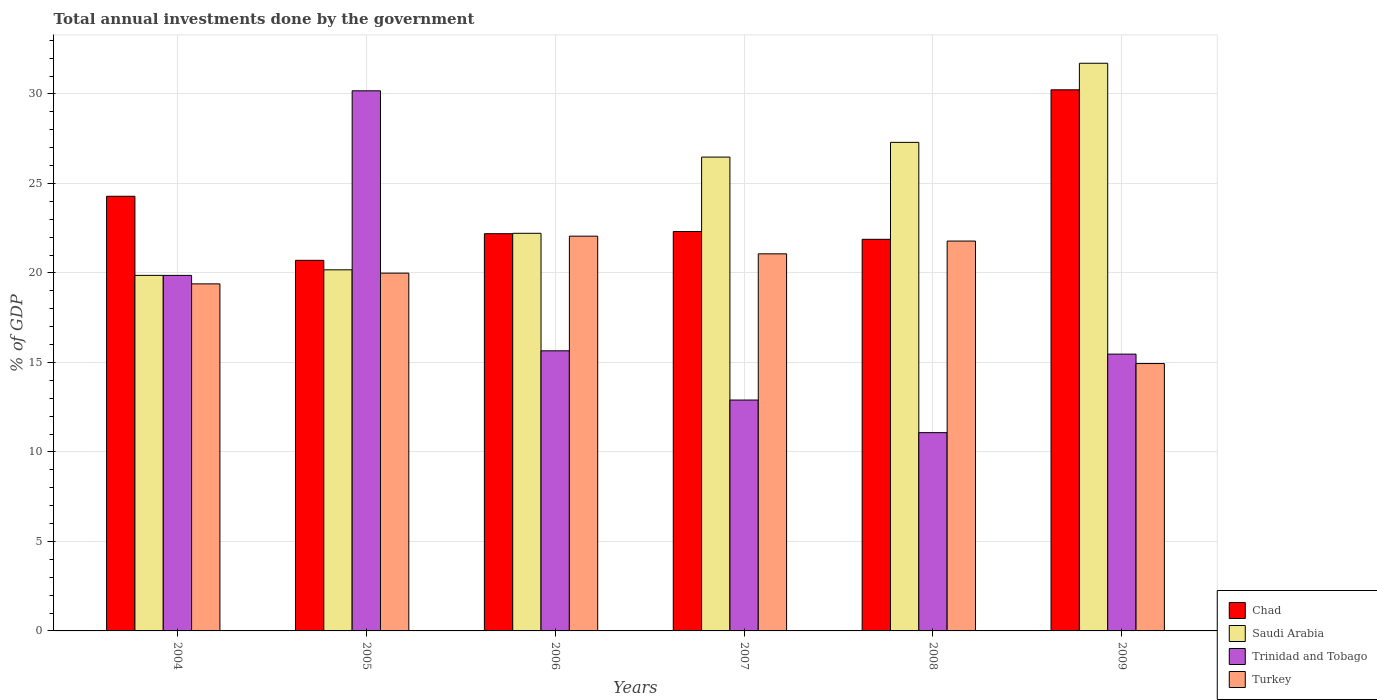How many groups of bars are there?
Keep it short and to the point. 6. Are the number of bars per tick equal to the number of legend labels?
Provide a succinct answer. Yes. How many bars are there on the 2nd tick from the right?
Your answer should be very brief. 4. What is the label of the 5th group of bars from the left?
Provide a short and direct response. 2008. What is the total annual investments done by the government in Saudi Arabia in 2005?
Your answer should be very brief. 20.17. Across all years, what is the maximum total annual investments done by the government in Trinidad and Tobago?
Keep it short and to the point. 30.18. Across all years, what is the minimum total annual investments done by the government in Turkey?
Keep it short and to the point. 14.94. In which year was the total annual investments done by the government in Turkey minimum?
Make the answer very short. 2009. What is the total total annual investments done by the government in Turkey in the graph?
Provide a short and direct response. 119.22. What is the difference between the total annual investments done by the government in Turkey in 2004 and that in 2005?
Give a very brief answer. -0.6. What is the difference between the total annual investments done by the government in Chad in 2008 and the total annual investments done by the government in Trinidad and Tobago in 2009?
Provide a succinct answer. 6.41. What is the average total annual investments done by the government in Chad per year?
Your answer should be very brief. 23.6. In the year 2009, what is the difference between the total annual investments done by the government in Saudi Arabia and total annual investments done by the government in Trinidad and Tobago?
Offer a terse response. 16.25. In how many years, is the total annual investments done by the government in Chad greater than 29 %?
Offer a terse response. 1. What is the ratio of the total annual investments done by the government in Trinidad and Tobago in 2008 to that in 2009?
Provide a short and direct response. 0.72. Is the total annual investments done by the government in Saudi Arabia in 2007 less than that in 2009?
Your response must be concise. Yes. What is the difference between the highest and the second highest total annual investments done by the government in Turkey?
Offer a terse response. 0.27. What is the difference between the highest and the lowest total annual investments done by the government in Saudi Arabia?
Ensure brevity in your answer.  11.85. Is it the case that in every year, the sum of the total annual investments done by the government in Chad and total annual investments done by the government in Trinidad and Tobago is greater than the sum of total annual investments done by the government in Turkey and total annual investments done by the government in Saudi Arabia?
Offer a very short reply. Yes. What does the 1st bar from the left in 2004 represents?
Give a very brief answer. Chad. What does the 2nd bar from the right in 2009 represents?
Make the answer very short. Trinidad and Tobago. How many bars are there?
Your response must be concise. 24. Are all the bars in the graph horizontal?
Keep it short and to the point. No. Does the graph contain any zero values?
Keep it short and to the point. No. How are the legend labels stacked?
Make the answer very short. Vertical. What is the title of the graph?
Ensure brevity in your answer.  Total annual investments done by the government. What is the label or title of the X-axis?
Your response must be concise. Years. What is the label or title of the Y-axis?
Your answer should be very brief. % of GDP. What is the % of GDP in Chad in 2004?
Offer a very short reply. 24.28. What is the % of GDP in Saudi Arabia in 2004?
Offer a terse response. 19.86. What is the % of GDP of Trinidad and Tobago in 2004?
Your response must be concise. 19.86. What is the % of GDP in Turkey in 2004?
Offer a very short reply. 19.39. What is the % of GDP of Chad in 2005?
Give a very brief answer. 20.7. What is the % of GDP in Saudi Arabia in 2005?
Keep it short and to the point. 20.17. What is the % of GDP of Trinidad and Tobago in 2005?
Provide a succinct answer. 30.18. What is the % of GDP in Turkey in 2005?
Provide a short and direct response. 19.99. What is the % of GDP in Chad in 2006?
Make the answer very short. 22.19. What is the % of GDP in Saudi Arabia in 2006?
Provide a short and direct response. 22.22. What is the % of GDP of Trinidad and Tobago in 2006?
Your answer should be compact. 15.65. What is the % of GDP of Turkey in 2006?
Your response must be concise. 22.05. What is the % of GDP in Chad in 2007?
Your answer should be compact. 22.32. What is the % of GDP in Saudi Arabia in 2007?
Ensure brevity in your answer.  26.47. What is the % of GDP in Trinidad and Tobago in 2007?
Your answer should be very brief. 12.9. What is the % of GDP of Turkey in 2007?
Keep it short and to the point. 21.07. What is the % of GDP in Chad in 2008?
Your answer should be very brief. 21.88. What is the % of GDP in Saudi Arabia in 2008?
Provide a short and direct response. 27.3. What is the % of GDP in Trinidad and Tobago in 2008?
Provide a succinct answer. 11.08. What is the % of GDP in Turkey in 2008?
Your response must be concise. 21.78. What is the % of GDP in Chad in 2009?
Give a very brief answer. 30.23. What is the % of GDP in Saudi Arabia in 2009?
Make the answer very short. 31.72. What is the % of GDP in Trinidad and Tobago in 2009?
Offer a very short reply. 15.46. What is the % of GDP in Turkey in 2009?
Provide a short and direct response. 14.94. Across all years, what is the maximum % of GDP of Chad?
Give a very brief answer. 30.23. Across all years, what is the maximum % of GDP in Saudi Arabia?
Offer a terse response. 31.72. Across all years, what is the maximum % of GDP of Trinidad and Tobago?
Keep it short and to the point. 30.18. Across all years, what is the maximum % of GDP of Turkey?
Provide a short and direct response. 22.05. Across all years, what is the minimum % of GDP in Chad?
Your answer should be very brief. 20.7. Across all years, what is the minimum % of GDP in Saudi Arabia?
Make the answer very short. 19.86. Across all years, what is the minimum % of GDP in Trinidad and Tobago?
Your answer should be compact. 11.08. Across all years, what is the minimum % of GDP in Turkey?
Give a very brief answer. 14.94. What is the total % of GDP in Chad in the graph?
Provide a succinct answer. 141.61. What is the total % of GDP of Saudi Arabia in the graph?
Ensure brevity in your answer.  147.74. What is the total % of GDP of Trinidad and Tobago in the graph?
Offer a very short reply. 105.13. What is the total % of GDP in Turkey in the graph?
Your answer should be very brief. 119.22. What is the difference between the % of GDP in Chad in 2004 and that in 2005?
Make the answer very short. 3.58. What is the difference between the % of GDP of Saudi Arabia in 2004 and that in 2005?
Offer a very short reply. -0.31. What is the difference between the % of GDP of Trinidad and Tobago in 2004 and that in 2005?
Your answer should be very brief. -10.31. What is the difference between the % of GDP in Turkey in 2004 and that in 2005?
Ensure brevity in your answer.  -0.6. What is the difference between the % of GDP in Chad in 2004 and that in 2006?
Give a very brief answer. 2.09. What is the difference between the % of GDP in Saudi Arabia in 2004 and that in 2006?
Offer a very short reply. -2.35. What is the difference between the % of GDP of Trinidad and Tobago in 2004 and that in 2006?
Offer a very short reply. 4.21. What is the difference between the % of GDP of Turkey in 2004 and that in 2006?
Offer a very short reply. -2.66. What is the difference between the % of GDP of Chad in 2004 and that in 2007?
Provide a succinct answer. 1.97. What is the difference between the % of GDP of Saudi Arabia in 2004 and that in 2007?
Provide a short and direct response. -6.61. What is the difference between the % of GDP of Trinidad and Tobago in 2004 and that in 2007?
Provide a short and direct response. 6.96. What is the difference between the % of GDP of Turkey in 2004 and that in 2007?
Your response must be concise. -1.68. What is the difference between the % of GDP of Chad in 2004 and that in 2008?
Offer a terse response. 2.4. What is the difference between the % of GDP of Saudi Arabia in 2004 and that in 2008?
Offer a very short reply. -7.43. What is the difference between the % of GDP in Trinidad and Tobago in 2004 and that in 2008?
Provide a succinct answer. 8.79. What is the difference between the % of GDP of Turkey in 2004 and that in 2008?
Make the answer very short. -2.39. What is the difference between the % of GDP in Chad in 2004 and that in 2009?
Keep it short and to the point. -5.95. What is the difference between the % of GDP of Saudi Arabia in 2004 and that in 2009?
Your answer should be very brief. -11.85. What is the difference between the % of GDP of Trinidad and Tobago in 2004 and that in 2009?
Keep it short and to the point. 4.4. What is the difference between the % of GDP in Turkey in 2004 and that in 2009?
Provide a short and direct response. 4.45. What is the difference between the % of GDP of Chad in 2005 and that in 2006?
Provide a succinct answer. -1.49. What is the difference between the % of GDP of Saudi Arabia in 2005 and that in 2006?
Offer a very short reply. -2.04. What is the difference between the % of GDP of Trinidad and Tobago in 2005 and that in 2006?
Give a very brief answer. 14.53. What is the difference between the % of GDP of Turkey in 2005 and that in 2006?
Your answer should be very brief. -2.07. What is the difference between the % of GDP of Chad in 2005 and that in 2007?
Offer a terse response. -1.61. What is the difference between the % of GDP in Saudi Arabia in 2005 and that in 2007?
Ensure brevity in your answer.  -6.3. What is the difference between the % of GDP in Trinidad and Tobago in 2005 and that in 2007?
Your answer should be very brief. 17.28. What is the difference between the % of GDP of Turkey in 2005 and that in 2007?
Offer a terse response. -1.08. What is the difference between the % of GDP of Chad in 2005 and that in 2008?
Offer a terse response. -1.17. What is the difference between the % of GDP in Saudi Arabia in 2005 and that in 2008?
Provide a short and direct response. -7.12. What is the difference between the % of GDP in Trinidad and Tobago in 2005 and that in 2008?
Provide a short and direct response. 19.1. What is the difference between the % of GDP in Turkey in 2005 and that in 2008?
Offer a very short reply. -1.79. What is the difference between the % of GDP of Chad in 2005 and that in 2009?
Keep it short and to the point. -9.53. What is the difference between the % of GDP in Saudi Arabia in 2005 and that in 2009?
Your answer should be compact. -11.54. What is the difference between the % of GDP of Trinidad and Tobago in 2005 and that in 2009?
Your response must be concise. 14.71. What is the difference between the % of GDP of Turkey in 2005 and that in 2009?
Offer a terse response. 5.05. What is the difference between the % of GDP of Chad in 2006 and that in 2007?
Give a very brief answer. -0.12. What is the difference between the % of GDP in Saudi Arabia in 2006 and that in 2007?
Your answer should be compact. -4.26. What is the difference between the % of GDP of Trinidad and Tobago in 2006 and that in 2007?
Provide a succinct answer. 2.75. What is the difference between the % of GDP of Turkey in 2006 and that in 2007?
Provide a short and direct response. 0.99. What is the difference between the % of GDP in Chad in 2006 and that in 2008?
Make the answer very short. 0.31. What is the difference between the % of GDP of Saudi Arabia in 2006 and that in 2008?
Make the answer very short. -5.08. What is the difference between the % of GDP in Trinidad and Tobago in 2006 and that in 2008?
Your answer should be compact. 4.57. What is the difference between the % of GDP of Turkey in 2006 and that in 2008?
Ensure brevity in your answer.  0.27. What is the difference between the % of GDP of Chad in 2006 and that in 2009?
Your answer should be compact. -8.04. What is the difference between the % of GDP of Saudi Arabia in 2006 and that in 2009?
Provide a short and direct response. -9.5. What is the difference between the % of GDP in Trinidad and Tobago in 2006 and that in 2009?
Make the answer very short. 0.18. What is the difference between the % of GDP in Turkey in 2006 and that in 2009?
Keep it short and to the point. 7.12. What is the difference between the % of GDP in Chad in 2007 and that in 2008?
Give a very brief answer. 0.44. What is the difference between the % of GDP in Saudi Arabia in 2007 and that in 2008?
Your answer should be very brief. -0.82. What is the difference between the % of GDP of Trinidad and Tobago in 2007 and that in 2008?
Give a very brief answer. 1.82. What is the difference between the % of GDP of Turkey in 2007 and that in 2008?
Provide a succinct answer. -0.71. What is the difference between the % of GDP of Chad in 2007 and that in 2009?
Ensure brevity in your answer.  -7.92. What is the difference between the % of GDP in Saudi Arabia in 2007 and that in 2009?
Provide a succinct answer. -5.24. What is the difference between the % of GDP in Trinidad and Tobago in 2007 and that in 2009?
Give a very brief answer. -2.57. What is the difference between the % of GDP of Turkey in 2007 and that in 2009?
Your answer should be very brief. 6.13. What is the difference between the % of GDP of Chad in 2008 and that in 2009?
Make the answer very short. -8.35. What is the difference between the % of GDP of Saudi Arabia in 2008 and that in 2009?
Your response must be concise. -4.42. What is the difference between the % of GDP of Trinidad and Tobago in 2008 and that in 2009?
Your answer should be compact. -4.39. What is the difference between the % of GDP in Turkey in 2008 and that in 2009?
Offer a terse response. 6.84. What is the difference between the % of GDP in Chad in 2004 and the % of GDP in Saudi Arabia in 2005?
Offer a terse response. 4.11. What is the difference between the % of GDP in Chad in 2004 and the % of GDP in Trinidad and Tobago in 2005?
Ensure brevity in your answer.  -5.89. What is the difference between the % of GDP in Chad in 2004 and the % of GDP in Turkey in 2005?
Provide a succinct answer. 4.29. What is the difference between the % of GDP in Saudi Arabia in 2004 and the % of GDP in Trinidad and Tobago in 2005?
Provide a short and direct response. -10.31. What is the difference between the % of GDP in Saudi Arabia in 2004 and the % of GDP in Turkey in 2005?
Offer a terse response. -0.12. What is the difference between the % of GDP in Trinidad and Tobago in 2004 and the % of GDP in Turkey in 2005?
Give a very brief answer. -0.13. What is the difference between the % of GDP of Chad in 2004 and the % of GDP of Saudi Arabia in 2006?
Your answer should be very brief. 2.07. What is the difference between the % of GDP of Chad in 2004 and the % of GDP of Trinidad and Tobago in 2006?
Provide a succinct answer. 8.63. What is the difference between the % of GDP in Chad in 2004 and the % of GDP in Turkey in 2006?
Make the answer very short. 2.23. What is the difference between the % of GDP in Saudi Arabia in 2004 and the % of GDP in Trinidad and Tobago in 2006?
Keep it short and to the point. 4.21. What is the difference between the % of GDP of Saudi Arabia in 2004 and the % of GDP of Turkey in 2006?
Give a very brief answer. -2.19. What is the difference between the % of GDP in Trinidad and Tobago in 2004 and the % of GDP in Turkey in 2006?
Your answer should be compact. -2.19. What is the difference between the % of GDP of Chad in 2004 and the % of GDP of Saudi Arabia in 2007?
Offer a very short reply. -2.19. What is the difference between the % of GDP in Chad in 2004 and the % of GDP in Trinidad and Tobago in 2007?
Ensure brevity in your answer.  11.38. What is the difference between the % of GDP in Chad in 2004 and the % of GDP in Turkey in 2007?
Make the answer very short. 3.22. What is the difference between the % of GDP of Saudi Arabia in 2004 and the % of GDP of Trinidad and Tobago in 2007?
Give a very brief answer. 6.97. What is the difference between the % of GDP of Saudi Arabia in 2004 and the % of GDP of Turkey in 2007?
Your response must be concise. -1.2. What is the difference between the % of GDP in Trinidad and Tobago in 2004 and the % of GDP in Turkey in 2007?
Make the answer very short. -1.2. What is the difference between the % of GDP in Chad in 2004 and the % of GDP in Saudi Arabia in 2008?
Your answer should be compact. -3.01. What is the difference between the % of GDP in Chad in 2004 and the % of GDP in Trinidad and Tobago in 2008?
Your response must be concise. 13.21. What is the difference between the % of GDP in Chad in 2004 and the % of GDP in Turkey in 2008?
Provide a succinct answer. 2.5. What is the difference between the % of GDP in Saudi Arabia in 2004 and the % of GDP in Trinidad and Tobago in 2008?
Your answer should be compact. 8.79. What is the difference between the % of GDP of Saudi Arabia in 2004 and the % of GDP of Turkey in 2008?
Provide a short and direct response. -1.92. What is the difference between the % of GDP in Trinidad and Tobago in 2004 and the % of GDP in Turkey in 2008?
Ensure brevity in your answer.  -1.92. What is the difference between the % of GDP in Chad in 2004 and the % of GDP in Saudi Arabia in 2009?
Provide a succinct answer. -7.43. What is the difference between the % of GDP of Chad in 2004 and the % of GDP of Trinidad and Tobago in 2009?
Provide a short and direct response. 8.82. What is the difference between the % of GDP of Chad in 2004 and the % of GDP of Turkey in 2009?
Keep it short and to the point. 9.35. What is the difference between the % of GDP in Saudi Arabia in 2004 and the % of GDP in Trinidad and Tobago in 2009?
Make the answer very short. 4.4. What is the difference between the % of GDP of Saudi Arabia in 2004 and the % of GDP of Turkey in 2009?
Make the answer very short. 4.93. What is the difference between the % of GDP in Trinidad and Tobago in 2004 and the % of GDP in Turkey in 2009?
Give a very brief answer. 4.93. What is the difference between the % of GDP of Chad in 2005 and the % of GDP of Saudi Arabia in 2006?
Offer a very short reply. -1.51. What is the difference between the % of GDP of Chad in 2005 and the % of GDP of Trinidad and Tobago in 2006?
Provide a short and direct response. 5.05. What is the difference between the % of GDP in Chad in 2005 and the % of GDP in Turkey in 2006?
Keep it short and to the point. -1.35. What is the difference between the % of GDP in Saudi Arabia in 2005 and the % of GDP in Trinidad and Tobago in 2006?
Your answer should be very brief. 4.53. What is the difference between the % of GDP of Saudi Arabia in 2005 and the % of GDP of Turkey in 2006?
Offer a very short reply. -1.88. What is the difference between the % of GDP of Trinidad and Tobago in 2005 and the % of GDP of Turkey in 2006?
Provide a succinct answer. 8.12. What is the difference between the % of GDP of Chad in 2005 and the % of GDP of Saudi Arabia in 2007?
Offer a terse response. -5.77. What is the difference between the % of GDP in Chad in 2005 and the % of GDP in Trinidad and Tobago in 2007?
Offer a terse response. 7.8. What is the difference between the % of GDP of Chad in 2005 and the % of GDP of Turkey in 2007?
Your answer should be compact. -0.36. What is the difference between the % of GDP in Saudi Arabia in 2005 and the % of GDP in Trinidad and Tobago in 2007?
Provide a succinct answer. 7.28. What is the difference between the % of GDP of Saudi Arabia in 2005 and the % of GDP of Turkey in 2007?
Make the answer very short. -0.89. What is the difference between the % of GDP of Trinidad and Tobago in 2005 and the % of GDP of Turkey in 2007?
Your response must be concise. 9.11. What is the difference between the % of GDP of Chad in 2005 and the % of GDP of Saudi Arabia in 2008?
Ensure brevity in your answer.  -6.59. What is the difference between the % of GDP in Chad in 2005 and the % of GDP in Trinidad and Tobago in 2008?
Make the answer very short. 9.63. What is the difference between the % of GDP of Chad in 2005 and the % of GDP of Turkey in 2008?
Offer a terse response. -1.08. What is the difference between the % of GDP in Saudi Arabia in 2005 and the % of GDP in Trinidad and Tobago in 2008?
Give a very brief answer. 9.1. What is the difference between the % of GDP in Saudi Arabia in 2005 and the % of GDP in Turkey in 2008?
Provide a succinct answer. -1.61. What is the difference between the % of GDP of Trinidad and Tobago in 2005 and the % of GDP of Turkey in 2008?
Offer a very short reply. 8.39. What is the difference between the % of GDP in Chad in 2005 and the % of GDP in Saudi Arabia in 2009?
Offer a very short reply. -11.01. What is the difference between the % of GDP of Chad in 2005 and the % of GDP of Trinidad and Tobago in 2009?
Your answer should be very brief. 5.24. What is the difference between the % of GDP of Chad in 2005 and the % of GDP of Turkey in 2009?
Ensure brevity in your answer.  5.77. What is the difference between the % of GDP of Saudi Arabia in 2005 and the % of GDP of Trinidad and Tobago in 2009?
Keep it short and to the point. 4.71. What is the difference between the % of GDP of Saudi Arabia in 2005 and the % of GDP of Turkey in 2009?
Your answer should be compact. 5.24. What is the difference between the % of GDP of Trinidad and Tobago in 2005 and the % of GDP of Turkey in 2009?
Provide a succinct answer. 15.24. What is the difference between the % of GDP in Chad in 2006 and the % of GDP in Saudi Arabia in 2007?
Make the answer very short. -4.28. What is the difference between the % of GDP of Chad in 2006 and the % of GDP of Trinidad and Tobago in 2007?
Offer a terse response. 9.29. What is the difference between the % of GDP of Chad in 2006 and the % of GDP of Turkey in 2007?
Your answer should be very brief. 1.13. What is the difference between the % of GDP in Saudi Arabia in 2006 and the % of GDP in Trinidad and Tobago in 2007?
Your answer should be very brief. 9.32. What is the difference between the % of GDP in Saudi Arabia in 2006 and the % of GDP in Turkey in 2007?
Ensure brevity in your answer.  1.15. What is the difference between the % of GDP of Trinidad and Tobago in 2006 and the % of GDP of Turkey in 2007?
Make the answer very short. -5.42. What is the difference between the % of GDP in Chad in 2006 and the % of GDP in Saudi Arabia in 2008?
Ensure brevity in your answer.  -5.1. What is the difference between the % of GDP of Chad in 2006 and the % of GDP of Trinidad and Tobago in 2008?
Make the answer very short. 11.12. What is the difference between the % of GDP of Chad in 2006 and the % of GDP of Turkey in 2008?
Keep it short and to the point. 0.41. What is the difference between the % of GDP in Saudi Arabia in 2006 and the % of GDP in Trinidad and Tobago in 2008?
Keep it short and to the point. 11.14. What is the difference between the % of GDP in Saudi Arabia in 2006 and the % of GDP in Turkey in 2008?
Ensure brevity in your answer.  0.43. What is the difference between the % of GDP of Trinidad and Tobago in 2006 and the % of GDP of Turkey in 2008?
Ensure brevity in your answer.  -6.13. What is the difference between the % of GDP in Chad in 2006 and the % of GDP in Saudi Arabia in 2009?
Your answer should be very brief. -9.52. What is the difference between the % of GDP of Chad in 2006 and the % of GDP of Trinidad and Tobago in 2009?
Provide a short and direct response. 6.73. What is the difference between the % of GDP of Chad in 2006 and the % of GDP of Turkey in 2009?
Provide a short and direct response. 7.26. What is the difference between the % of GDP in Saudi Arabia in 2006 and the % of GDP in Trinidad and Tobago in 2009?
Keep it short and to the point. 6.75. What is the difference between the % of GDP in Saudi Arabia in 2006 and the % of GDP in Turkey in 2009?
Provide a short and direct response. 7.28. What is the difference between the % of GDP in Trinidad and Tobago in 2006 and the % of GDP in Turkey in 2009?
Your answer should be compact. 0.71. What is the difference between the % of GDP in Chad in 2007 and the % of GDP in Saudi Arabia in 2008?
Offer a very short reply. -4.98. What is the difference between the % of GDP in Chad in 2007 and the % of GDP in Trinidad and Tobago in 2008?
Your answer should be very brief. 11.24. What is the difference between the % of GDP of Chad in 2007 and the % of GDP of Turkey in 2008?
Provide a short and direct response. 0.53. What is the difference between the % of GDP in Saudi Arabia in 2007 and the % of GDP in Trinidad and Tobago in 2008?
Give a very brief answer. 15.39. What is the difference between the % of GDP in Saudi Arabia in 2007 and the % of GDP in Turkey in 2008?
Keep it short and to the point. 4.69. What is the difference between the % of GDP of Trinidad and Tobago in 2007 and the % of GDP of Turkey in 2008?
Your answer should be compact. -8.88. What is the difference between the % of GDP of Chad in 2007 and the % of GDP of Saudi Arabia in 2009?
Offer a terse response. -9.4. What is the difference between the % of GDP in Chad in 2007 and the % of GDP in Trinidad and Tobago in 2009?
Your answer should be compact. 6.85. What is the difference between the % of GDP in Chad in 2007 and the % of GDP in Turkey in 2009?
Give a very brief answer. 7.38. What is the difference between the % of GDP in Saudi Arabia in 2007 and the % of GDP in Trinidad and Tobago in 2009?
Keep it short and to the point. 11.01. What is the difference between the % of GDP of Saudi Arabia in 2007 and the % of GDP of Turkey in 2009?
Your response must be concise. 11.54. What is the difference between the % of GDP of Trinidad and Tobago in 2007 and the % of GDP of Turkey in 2009?
Keep it short and to the point. -2.04. What is the difference between the % of GDP of Chad in 2008 and the % of GDP of Saudi Arabia in 2009?
Your answer should be very brief. -9.84. What is the difference between the % of GDP in Chad in 2008 and the % of GDP in Trinidad and Tobago in 2009?
Your answer should be very brief. 6.41. What is the difference between the % of GDP in Chad in 2008 and the % of GDP in Turkey in 2009?
Offer a terse response. 6.94. What is the difference between the % of GDP of Saudi Arabia in 2008 and the % of GDP of Trinidad and Tobago in 2009?
Give a very brief answer. 11.83. What is the difference between the % of GDP in Saudi Arabia in 2008 and the % of GDP in Turkey in 2009?
Provide a succinct answer. 12.36. What is the difference between the % of GDP in Trinidad and Tobago in 2008 and the % of GDP in Turkey in 2009?
Provide a short and direct response. -3.86. What is the average % of GDP of Chad per year?
Your response must be concise. 23.6. What is the average % of GDP in Saudi Arabia per year?
Your answer should be very brief. 24.62. What is the average % of GDP of Trinidad and Tobago per year?
Your response must be concise. 17.52. What is the average % of GDP in Turkey per year?
Provide a succinct answer. 19.87. In the year 2004, what is the difference between the % of GDP of Chad and % of GDP of Saudi Arabia?
Your answer should be very brief. 4.42. In the year 2004, what is the difference between the % of GDP of Chad and % of GDP of Trinidad and Tobago?
Make the answer very short. 4.42. In the year 2004, what is the difference between the % of GDP in Chad and % of GDP in Turkey?
Your answer should be very brief. 4.89. In the year 2004, what is the difference between the % of GDP of Saudi Arabia and % of GDP of Trinidad and Tobago?
Make the answer very short. 0. In the year 2004, what is the difference between the % of GDP in Saudi Arabia and % of GDP in Turkey?
Offer a very short reply. 0.47. In the year 2004, what is the difference between the % of GDP in Trinidad and Tobago and % of GDP in Turkey?
Your response must be concise. 0.47. In the year 2005, what is the difference between the % of GDP in Chad and % of GDP in Saudi Arabia?
Offer a very short reply. 0.53. In the year 2005, what is the difference between the % of GDP in Chad and % of GDP in Trinidad and Tobago?
Your answer should be very brief. -9.47. In the year 2005, what is the difference between the % of GDP in Chad and % of GDP in Turkey?
Provide a short and direct response. 0.71. In the year 2005, what is the difference between the % of GDP of Saudi Arabia and % of GDP of Trinidad and Tobago?
Offer a very short reply. -10. In the year 2005, what is the difference between the % of GDP in Saudi Arabia and % of GDP in Turkey?
Provide a succinct answer. 0.19. In the year 2005, what is the difference between the % of GDP of Trinidad and Tobago and % of GDP of Turkey?
Keep it short and to the point. 10.19. In the year 2006, what is the difference between the % of GDP in Chad and % of GDP in Saudi Arabia?
Offer a very short reply. -0.02. In the year 2006, what is the difference between the % of GDP in Chad and % of GDP in Trinidad and Tobago?
Your answer should be compact. 6.54. In the year 2006, what is the difference between the % of GDP of Chad and % of GDP of Turkey?
Offer a terse response. 0.14. In the year 2006, what is the difference between the % of GDP in Saudi Arabia and % of GDP in Trinidad and Tobago?
Offer a terse response. 6.57. In the year 2006, what is the difference between the % of GDP of Saudi Arabia and % of GDP of Turkey?
Give a very brief answer. 0.16. In the year 2006, what is the difference between the % of GDP in Trinidad and Tobago and % of GDP in Turkey?
Provide a short and direct response. -6.41. In the year 2007, what is the difference between the % of GDP of Chad and % of GDP of Saudi Arabia?
Your answer should be compact. -4.16. In the year 2007, what is the difference between the % of GDP in Chad and % of GDP in Trinidad and Tobago?
Your answer should be compact. 9.42. In the year 2007, what is the difference between the % of GDP in Chad and % of GDP in Turkey?
Your answer should be compact. 1.25. In the year 2007, what is the difference between the % of GDP of Saudi Arabia and % of GDP of Trinidad and Tobago?
Offer a terse response. 13.57. In the year 2007, what is the difference between the % of GDP of Saudi Arabia and % of GDP of Turkey?
Give a very brief answer. 5.41. In the year 2007, what is the difference between the % of GDP in Trinidad and Tobago and % of GDP in Turkey?
Your answer should be compact. -8.17. In the year 2008, what is the difference between the % of GDP of Chad and % of GDP of Saudi Arabia?
Your answer should be compact. -5.42. In the year 2008, what is the difference between the % of GDP in Chad and % of GDP in Trinidad and Tobago?
Offer a very short reply. 10.8. In the year 2008, what is the difference between the % of GDP in Chad and % of GDP in Turkey?
Give a very brief answer. 0.1. In the year 2008, what is the difference between the % of GDP in Saudi Arabia and % of GDP in Trinidad and Tobago?
Your answer should be compact. 16.22. In the year 2008, what is the difference between the % of GDP in Saudi Arabia and % of GDP in Turkey?
Your response must be concise. 5.51. In the year 2008, what is the difference between the % of GDP of Trinidad and Tobago and % of GDP of Turkey?
Offer a very short reply. -10.7. In the year 2009, what is the difference between the % of GDP of Chad and % of GDP of Saudi Arabia?
Keep it short and to the point. -1.48. In the year 2009, what is the difference between the % of GDP of Chad and % of GDP of Trinidad and Tobago?
Offer a terse response. 14.77. In the year 2009, what is the difference between the % of GDP in Chad and % of GDP in Turkey?
Offer a terse response. 15.29. In the year 2009, what is the difference between the % of GDP of Saudi Arabia and % of GDP of Trinidad and Tobago?
Keep it short and to the point. 16.25. In the year 2009, what is the difference between the % of GDP of Saudi Arabia and % of GDP of Turkey?
Your answer should be very brief. 16.78. In the year 2009, what is the difference between the % of GDP in Trinidad and Tobago and % of GDP in Turkey?
Your response must be concise. 0.53. What is the ratio of the % of GDP in Chad in 2004 to that in 2005?
Ensure brevity in your answer.  1.17. What is the ratio of the % of GDP in Saudi Arabia in 2004 to that in 2005?
Your answer should be compact. 0.98. What is the ratio of the % of GDP in Trinidad and Tobago in 2004 to that in 2005?
Provide a short and direct response. 0.66. What is the ratio of the % of GDP of Turkey in 2004 to that in 2005?
Provide a succinct answer. 0.97. What is the ratio of the % of GDP in Chad in 2004 to that in 2006?
Your answer should be very brief. 1.09. What is the ratio of the % of GDP of Saudi Arabia in 2004 to that in 2006?
Offer a terse response. 0.89. What is the ratio of the % of GDP in Trinidad and Tobago in 2004 to that in 2006?
Keep it short and to the point. 1.27. What is the ratio of the % of GDP in Turkey in 2004 to that in 2006?
Offer a very short reply. 0.88. What is the ratio of the % of GDP of Chad in 2004 to that in 2007?
Offer a terse response. 1.09. What is the ratio of the % of GDP in Saudi Arabia in 2004 to that in 2007?
Keep it short and to the point. 0.75. What is the ratio of the % of GDP in Trinidad and Tobago in 2004 to that in 2007?
Give a very brief answer. 1.54. What is the ratio of the % of GDP of Turkey in 2004 to that in 2007?
Offer a terse response. 0.92. What is the ratio of the % of GDP of Chad in 2004 to that in 2008?
Your answer should be very brief. 1.11. What is the ratio of the % of GDP of Saudi Arabia in 2004 to that in 2008?
Ensure brevity in your answer.  0.73. What is the ratio of the % of GDP in Trinidad and Tobago in 2004 to that in 2008?
Keep it short and to the point. 1.79. What is the ratio of the % of GDP in Turkey in 2004 to that in 2008?
Provide a succinct answer. 0.89. What is the ratio of the % of GDP in Chad in 2004 to that in 2009?
Ensure brevity in your answer.  0.8. What is the ratio of the % of GDP in Saudi Arabia in 2004 to that in 2009?
Offer a terse response. 0.63. What is the ratio of the % of GDP in Trinidad and Tobago in 2004 to that in 2009?
Make the answer very short. 1.28. What is the ratio of the % of GDP in Turkey in 2004 to that in 2009?
Provide a succinct answer. 1.3. What is the ratio of the % of GDP of Chad in 2005 to that in 2006?
Your answer should be compact. 0.93. What is the ratio of the % of GDP in Saudi Arabia in 2005 to that in 2006?
Give a very brief answer. 0.91. What is the ratio of the % of GDP in Trinidad and Tobago in 2005 to that in 2006?
Offer a terse response. 1.93. What is the ratio of the % of GDP of Turkey in 2005 to that in 2006?
Keep it short and to the point. 0.91. What is the ratio of the % of GDP of Chad in 2005 to that in 2007?
Provide a succinct answer. 0.93. What is the ratio of the % of GDP in Saudi Arabia in 2005 to that in 2007?
Ensure brevity in your answer.  0.76. What is the ratio of the % of GDP of Trinidad and Tobago in 2005 to that in 2007?
Offer a terse response. 2.34. What is the ratio of the % of GDP of Turkey in 2005 to that in 2007?
Provide a succinct answer. 0.95. What is the ratio of the % of GDP of Chad in 2005 to that in 2008?
Your response must be concise. 0.95. What is the ratio of the % of GDP in Saudi Arabia in 2005 to that in 2008?
Offer a terse response. 0.74. What is the ratio of the % of GDP of Trinidad and Tobago in 2005 to that in 2008?
Give a very brief answer. 2.72. What is the ratio of the % of GDP of Turkey in 2005 to that in 2008?
Make the answer very short. 0.92. What is the ratio of the % of GDP in Chad in 2005 to that in 2009?
Your answer should be very brief. 0.68. What is the ratio of the % of GDP in Saudi Arabia in 2005 to that in 2009?
Provide a short and direct response. 0.64. What is the ratio of the % of GDP of Trinidad and Tobago in 2005 to that in 2009?
Keep it short and to the point. 1.95. What is the ratio of the % of GDP of Turkey in 2005 to that in 2009?
Give a very brief answer. 1.34. What is the ratio of the % of GDP in Chad in 2006 to that in 2007?
Ensure brevity in your answer.  0.99. What is the ratio of the % of GDP in Saudi Arabia in 2006 to that in 2007?
Your response must be concise. 0.84. What is the ratio of the % of GDP in Trinidad and Tobago in 2006 to that in 2007?
Your response must be concise. 1.21. What is the ratio of the % of GDP of Turkey in 2006 to that in 2007?
Give a very brief answer. 1.05. What is the ratio of the % of GDP in Chad in 2006 to that in 2008?
Offer a very short reply. 1.01. What is the ratio of the % of GDP in Saudi Arabia in 2006 to that in 2008?
Your answer should be very brief. 0.81. What is the ratio of the % of GDP in Trinidad and Tobago in 2006 to that in 2008?
Make the answer very short. 1.41. What is the ratio of the % of GDP in Turkey in 2006 to that in 2008?
Your answer should be very brief. 1.01. What is the ratio of the % of GDP of Chad in 2006 to that in 2009?
Your answer should be compact. 0.73. What is the ratio of the % of GDP of Saudi Arabia in 2006 to that in 2009?
Provide a short and direct response. 0.7. What is the ratio of the % of GDP in Trinidad and Tobago in 2006 to that in 2009?
Your answer should be compact. 1.01. What is the ratio of the % of GDP in Turkey in 2006 to that in 2009?
Offer a very short reply. 1.48. What is the ratio of the % of GDP in Chad in 2007 to that in 2008?
Keep it short and to the point. 1.02. What is the ratio of the % of GDP of Saudi Arabia in 2007 to that in 2008?
Offer a very short reply. 0.97. What is the ratio of the % of GDP of Trinidad and Tobago in 2007 to that in 2008?
Your response must be concise. 1.16. What is the ratio of the % of GDP in Turkey in 2007 to that in 2008?
Your answer should be compact. 0.97. What is the ratio of the % of GDP in Chad in 2007 to that in 2009?
Your answer should be compact. 0.74. What is the ratio of the % of GDP in Saudi Arabia in 2007 to that in 2009?
Make the answer very short. 0.83. What is the ratio of the % of GDP of Trinidad and Tobago in 2007 to that in 2009?
Give a very brief answer. 0.83. What is the ratio of the % of GDP in Turkey in 2007 to that in 2009?
Your answer should be compact. 1.41. What is the ratio of the % of GDP of Chad in 2008 to that in 2009?
Make the answer very short. 0.72. What is the ratio of the % of GDP of Saudi Arabia in 2008 to that in 2009?
Give a very brief answer. 0.86. What is the ratio of the % of GDP of Trinidad and Tobago in 2008 to that in 2009?
Your answer should be compact. 0.72. What is the ratio of the % of GDP in Turkey in 2008 to that in 2009?
Ensure brevity in your answer.  1.46. What is the difference between the highest and the second highest % of GDP in Chad?
Your response must be concise. 5.95. What is the difference between the highest and the second highest % of GDP of Saudi Arabia?
Offer a very short reply. 4.42. What is the difference between the highest and the second highest % of GDP in Trinidad and Tobago?
Offer a terse response. 10.31. What is the difference between the highest and the second highest % of GDP of Turkey?
Ensure brevity in your answer.  0.27. What is the difference between the highest and the lowest % of GDP of Chad?
Your answer should be very brief. 9.53. What is the difference between the highest and the lowest % of GDP of Saudi Arabia?
Give a very brief answer. 11.85. What is the difference between the highest and the lowest % of GDP of Trinidad and Tobago?
Ensure brevity in your answer.  19.1. What is the difference between the highest and the lowest % of GDP in Turkey?
Your answer should be very brief. 7.12. 